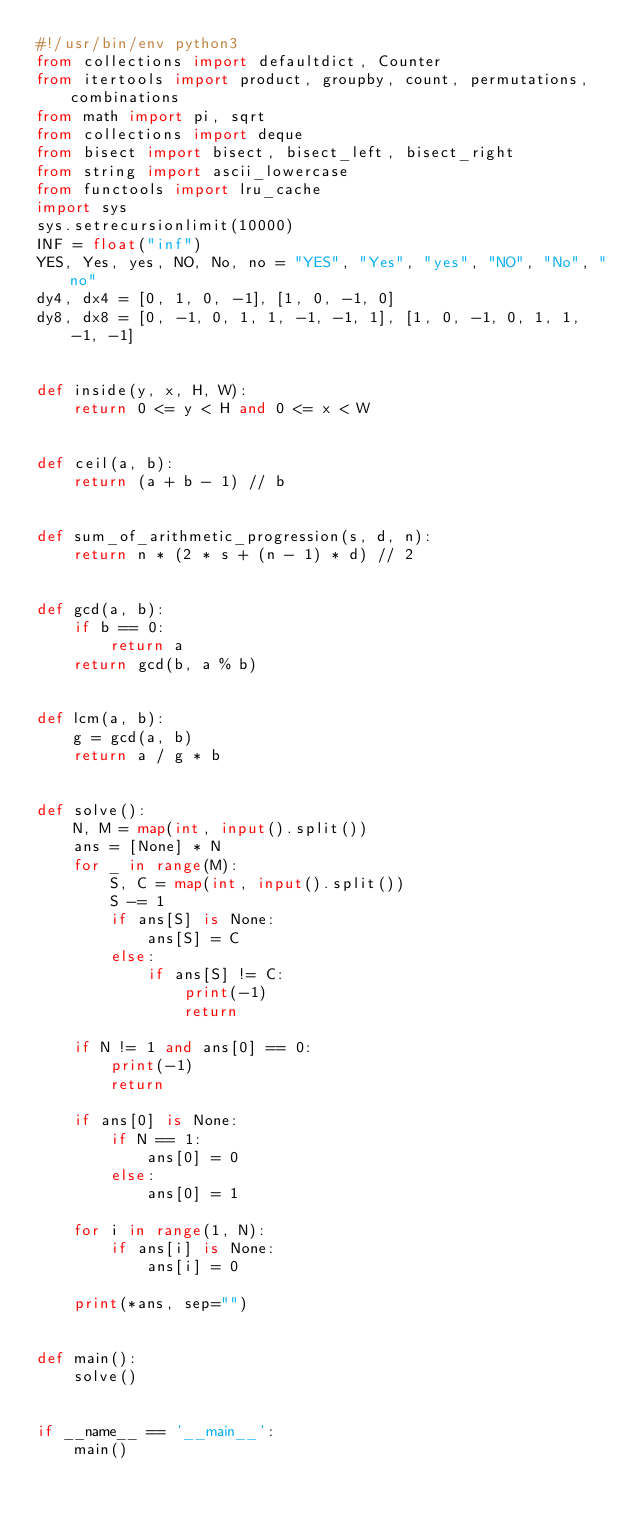Convert code to text. <code><loc_0><loc_0><loc_500><loc_500><_Python_>#!/usr/bin/env python3
from collections import defaultdict, Counter
from itertools import product, groupby, count, permutations, combinations
from math import pi, sqrt
from collections import deque
from bisect import bisect, bisect_left, bisect_right
from string import ascii_lowercase
from functools import lru_cache
import sys
sys.setrecursionlimit(10000)
INF = float("inf")
YES, Yes, yes, NO, No, no = "YES", "Yes", "yes", "NO", "No", "no"
dy4, dx4 = [0, 1, 0, -1], [1, 0, -1, 0]
dy8, dx8 = [0, -1, 0, 1, 1, -1, -1, 1], [1, 0, -1, 0, 1, 1, -1, -1]


def inside(y, x, H, W):
    return 0 <= y < H and 0 <= x < W


def ceil(a, b):
    return (a + b - 1) // b


def sum_of_arithmetic_progression(s, d, n):
    return n * (2 * s + (n - 1) * d) // 2


def gcd(a, b):
    if b == 0:
        return a
    return gcd(b, a % b)


def lcm(a, b):
    g = gcd(a, b)
    return a / g * b


def solve():
    N, M = map(int, input().split())
    ans = [None] * N
    for _ in range(M):
        S, C = map(int, input().split())
        S -= 1
        if ans[S] is None:
            ans[S] = C
        else:
            if ans[S] != C:
                print(-1)
                return

    if N != 1 and ans[0] == 0:
        print(-1)
        return

    if ans[0] is None:
        if N == 1:
            ans[0] = 0
        else:
            ans[0] = 1

    for i in range(1, N):
        if ans[i] is None:
            ans[i] = 0

    print(*ans, sep="")


def main():
    solve()


if __name__ == '__main__':
    main()
</code> 